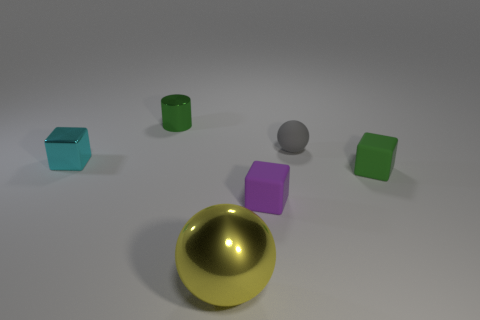How does the arrangement of objects in the image influence the perception of space? The arrangement of the objects creates a sense of depth and dimensionality within the two-dimensional frame of the image. The placement of objects at varying distances from the viewpoint, with some overlap, helps build a three-dimensional effect and suggests spatial relations between them. 